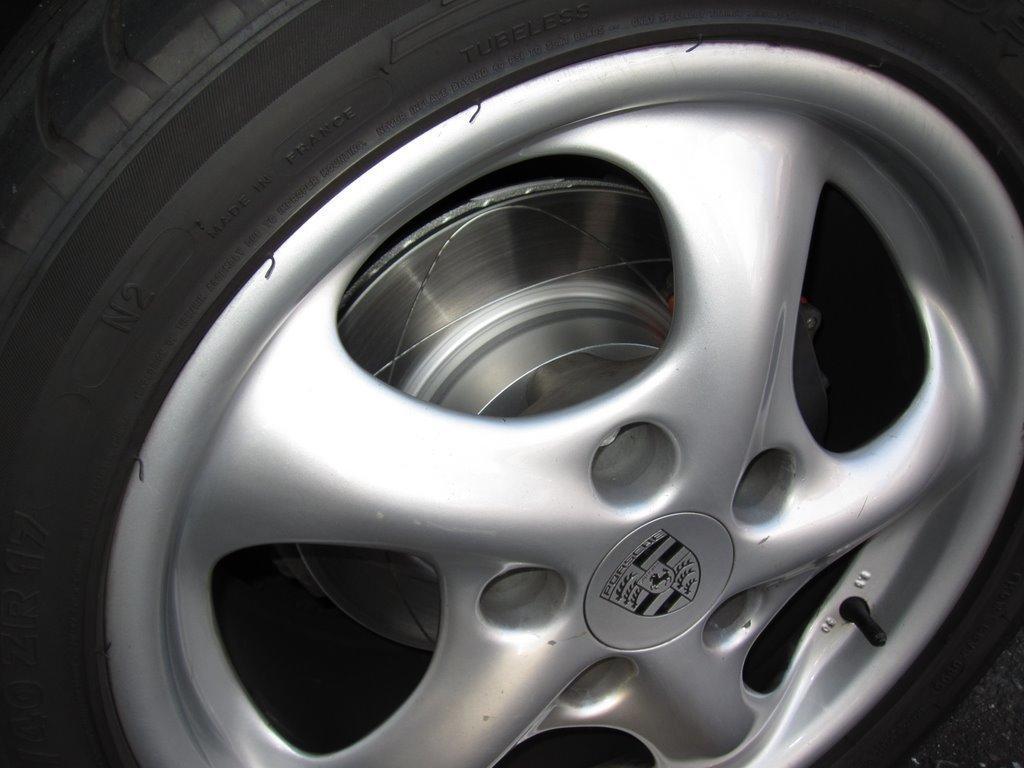In one or two sentences, can you explain what this image depicts? In this picture we can see a Tyre with a logo on it. 